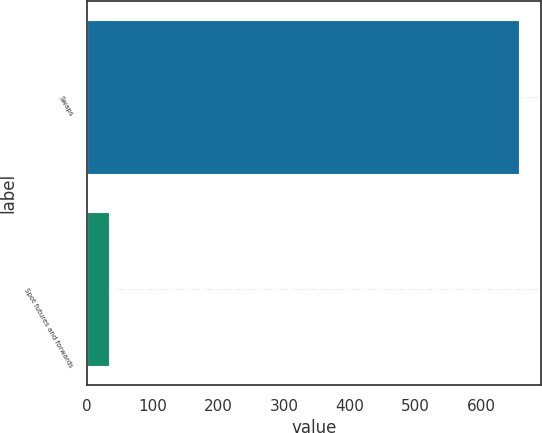Convert chart to OTSL. <chart><loc_0><loc_0><loc_500><loc_500><bar_chart><fcel>Swaps<fcel>Spot futures and forwards<nl><fcel>658.4<fcel>33.5<nl></chart> 